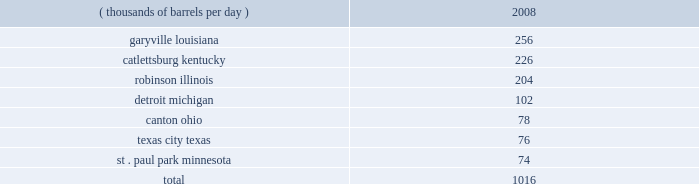Our refineries processed 944 mbpd of crude oil and 207 mbpd of other charge and blend stocks .
The table below sets forth the location and daily crude oil refining capacity of each of our refineries as of december 31 , 2008 .
Crude oil refining capacity ( thousands of barrels per day ) 2008 .
Our refineries include crude oil atmospheric and vacuum distillation , fluid catalytic cracking , catalytic reforming , desulfurization and sulfur recovery units .
The refineries process a wide variety of crude oils and produce numerous refined products , ranging from transportation fuels , such as reformulated gasolines , blend- grade gasolines intended for blending with fuel ethanol and ultra-low sulfur diesel fuel , to heavy fuel oil and asphalt .
Additionally , we manufacture aromatics , cumene , propane , propylene , sulfur and maleic anhydride .
Our refineries are integrated with each other via pipelines , terminals and barges to maximize operating efficiency .
The transportation links that connect our refineries allow the movement of intermediate products between refineries to optimize operations , produce higher margin products and utilize our processing capacity efficiently .
Our garyville , louisiana , refinery is located along the mississippi river in southeastern louisiana .
The garyville refinery processes heavy sour crude oil into products such as gasoline , distillates , sulfur , asphalt , propane , polymer grade propylene , isobutane and coke .
In 2006 , we approved an expansion of our garyville refinery by 180 mbpd to 436 mbpd , with a currently projected cost of $ 3.35 billion ( excluding capitalized interest ) .
Construction commenced in early 2007 and is continuing on schedule .
We estimate that , as of december 31 , 2008 , this project is approximately 75 percent complete .
We expect to complete the expansion in late 2009 .
Our catlettsburg , kentucky , refinery is located in northeastern kentucky on the western bank of the big sandy river , near the confluence with the ohio river .
The catlettsburg refinery processes sweet and sour crude oils into products such as gasoline , asphalt , diesel , jet fuel , petrochemicals , propane , propylene and sulfur .
Our robinson , illinois , refinery is located in the southeastern illinois town of robinson .
The robinson refinery processes sweet and sour crude oils into products such as multiple grades of gasoline , jet fuel , kerosene , diesel fuel , propane , propylene , sulfur and anode-grade coke .
Our detroit , michigan , refinery is located near interstate 75 in southwest detroit .
The detroit refinery processes light sweet and heavy sour crude oils , including canadian crude oils , into products such as gasoline , diesel , asphalt , slurry , propane , chemical grade propylene and sulfur .
In 2007 , we approved a heavy oil upgrading and expansion project at our detroit , michigan , refinery , with a current projected cost of $ 2.2 billion ( excluding capitalized interest ) .
This project will enable the refinery to process additional heavy sour crude oils , including canadian bitumen blends , and will increase its crude oil refining capacity by about 15 percent .
Construction began in the first half of 2008 and is presently expected to be complete in mid-2012 .
Our canton , ohio , refinery is located approximately 60 miles southeast of cleveland , ohio .
The canton refinery processes sweet and sour crude oils into products such as gasoline , diesel fuels , kerosene , propane , sulfur , asphalt , roofing flux , home heating oil and no .
6 industrial fuel oil .
Our texas city , texas , refinery is located on the texas gulf coast approximately 30 miles south of houston , texas .
The refinery processes sweet crude oil into products such as gasoline , propane , chemical grade propylene , slurry , sulfur and aromatics .
Our st .
Paul park , minnesota , refinery is located in st .
Paul park , a suburb of minneapolis-st .
Paul .
The st .
Paul park refinery processes predominantly canadian crude oils into products such as gasoline , diesel , jet fuel , kerosene , asphalt , propane , propylene and sulfur. .
In 2006 , what was the increase in capacity of our garyville refinery by mbpd ? 
Computations: (436 - 180)
Answer: 256.0. Our refineries processed 944 mbpd of crude oil and 207 mbpd of other charge and blend stocks .
The table below sets forth the location and daily crude oil refining capacity of each of our refineries as of december 31 , 2008 .
Crude oil refining capacity ( thousands of barrels per day ) 2008 .
Our refineries include crude oil atmospheric and vacuum distillation , fluid catalytic cracking , catalytic reforming , desulfurization and sulfur recovery units .
The refineries process a wide variety of crude oils and produce numerous refined products , ranging from transportation fuels , such as reformulated gasolines , blend- grade gasolines intended for blending with fuel ethanol and ultra-low sulfur diesel fuel , to heavy fuel oil and asphalt .
Additionally , we manufacture aromatics , cumene , propane , propylene , sulfur and maleic anhydride .
Our refineries are integrated with each other via pipelines , terminals and barges to maximize operating efficiency .
The transportation links that connect our refineries allow the movement of intermediate products between refineries to optimize operations , produce higher margin products and utilize our processing capacity efficiently .
Our garyville , louisiana , refinery is located along the mississippi river in southeastern louisiana .
The garyville refinery processes heavy sour crude oil into products such as gasoline , distillates , sulfur , asphalt , propane , polymer grade propylene , isobutane and coke .
In 2006 , we approved an expansion of our garyville refinery by 180 mbpd to 436 mbpd , with a currently projected cost of $ 3.35 billion ( excluding capitalized interest ) .
Construction commenced in early 2007 and is continuing on schedule .
We estimate that , as of december 31 , 2008 , this project is approximately 75 percent complete .
We expect to complete the expansion in late 2009 .
Our catlettsburg , kentucky , refinery is located in northeastern kentucky on the western bank of the big sandy river , near the confluence with the ohio river .
The catlettsburg refinery processes sweet and sour crude oils into products such as gasoline , asphalt , diesel , jet fuel , petrochemicals , propane , propylene and sulfur .
Our robinson , illinois , refinery is located in the southeastern illinois town of robinson .
The robinson refinery processes sweet and sour crude oils into products such as multiple grades of gasoline , jet fuel , kerosene , diesel fuel , propane , propylene , sulfur and anode-grade coke .
Our detroit , michigan , refinery is located near interstate 75 in southwest detroit .
The detroit refinery processes light sweet and heavy sour crude oils , including canadian crude oils , into products such as gasoline , diesel , asphalt , slurry , propane , chemical grade propylene and sulfur .
In 2007 , we approved a heavy oil upgrading and expansion project at our detroit , michigan , refinery , with a current projected cost of $ 2.2 billion ( excluding capitalized interest ) .
This project will enable the refinery to process additional heavy sour crude oils , including canadian bitumen blends , and will increase its crude oil refining capacity by about 15 percent .
Construction began in the first half of 2008 and is presently expected to be complete in mid-2012 .
Our canton , ohio , refinery is located approximately 60 miles southeast of cleveland , ohio .
The canton refinery processes sweet and sour crude oils into products such as gasoline , diesel fuels , kerosene , propane , sulfur , asphalt , roofing flux , home heating oil and no .
6 industrial fuel oil .
Our texas city , texas , refinery is located on the texas gulf coast approximately 30 miles south of houston , texas .
The refinery processes sweet crude oil into products such as gasoline , propane , chemical grade propylene , slurry , sulfur and aromatics .
Our st .
Paul park , minnesota , refinery is located in st .
Paul park , a suburb of minneapolis-st .
Paul .
The st .
Paul park refinery processes predominantly canadian crude oils into products such as gasoline , diesel , jet fuel , kerosene , asphalt , propane , propylene and sulfur. .
Did ohio have larger refining capacity than michigan? 
Computations: (78 > 102)
Answer: no. 